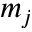<formula> <loc_0><loc_0><loc_500><loc_500>m _ { j }</formula> 